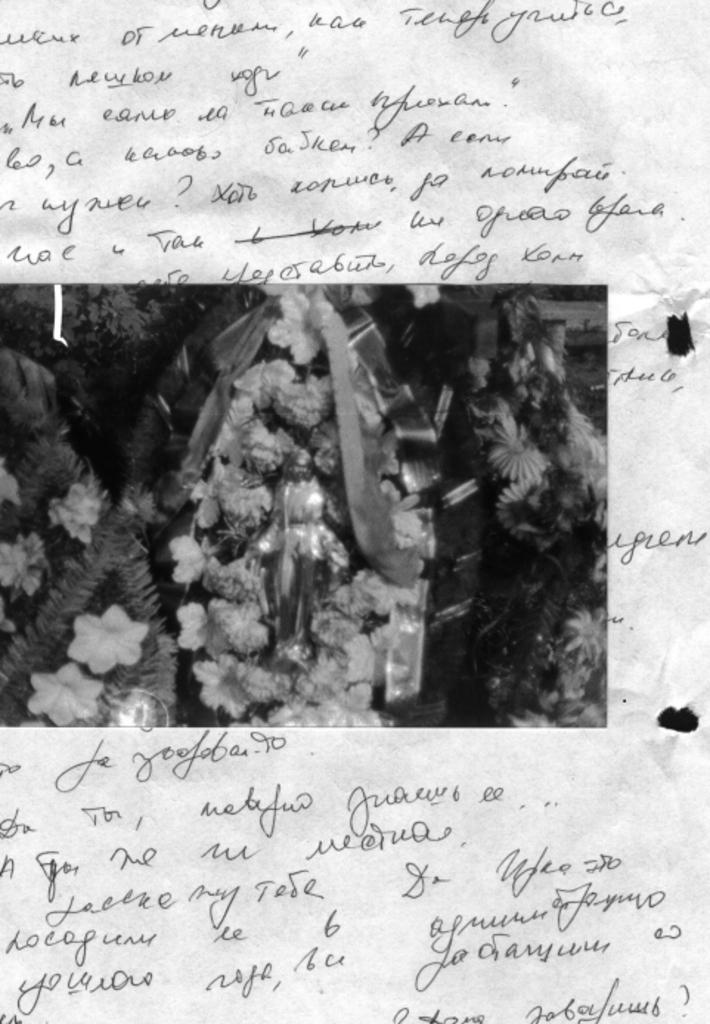What is present on the paper in the image? There is a paper with text in the image, and there is an image in the center of the paper. Can you describe the text on the paper? Unfortunately, the specific text on the paper cannot be determined from the image alone. What is the main subject of the image in the center of the paper? The main subject of the image in the center of the paper cannot be determined from the image alone. How many sponges are used to create the image on the paper? There are no sponges mentioned or visible in the image. What type of sticks are used to draw the text on the paper? There is no indication of sticks being used to draw the text on the paper; the text appears to be printed or written. 